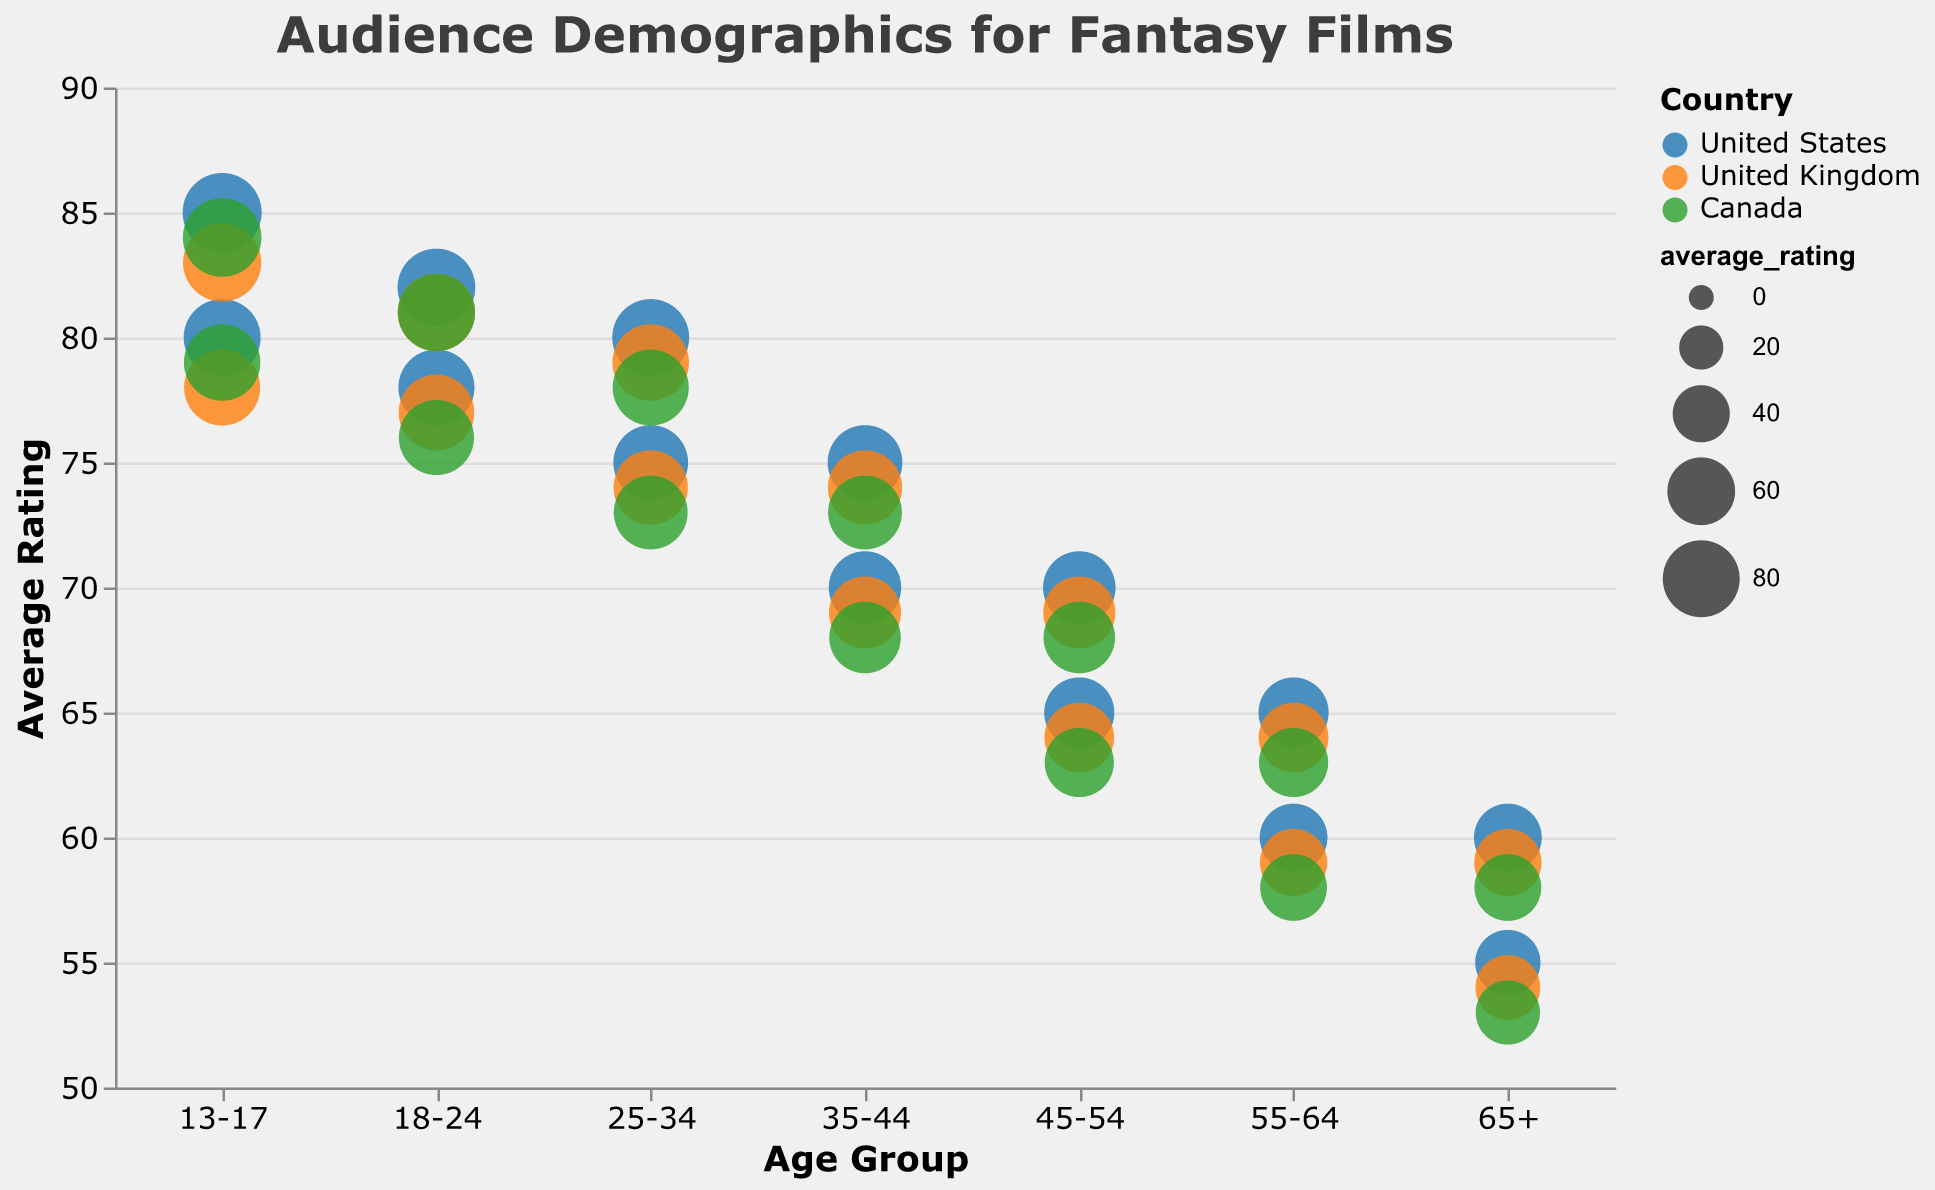What is the title of the chart? The title is displayed at the top of the chart and usually summarizes the content presented in the chart. Here, the title reads "Audience Demographics for Fantasy Films".
Answer: Audience Demographics for Fantasy Films How many age groups are represented in the chart? The age groups are represented on the x-axis and there are distinct labels for each group. By counting these labels, we can determine the number of age groups.
Answer: 7 Which gender has a higher average rating in the age group 13-17 in the United States? For the age group 13-17 in the United States, identify the shape type and look for the one with the higher y-axis value (average rating). Female (triangle) has an average rating of 85 while Male (circle) has an average rating of 80.
Answer: Female Among the three countries, which country's color represents Canada? Legend in the chart shows the correlation between the countries and their colors. According to the legend, Canada is represented by green.
Answer: Green What is the difference in average rating between the 13-17 age group and the 65+ age group for males in the United Kingdom? Locate the average ratings for males in the United Kingdom for the age groups 13-17 and 65+. For the 13-17 age group, the rating is 78. For the 65+ age group, it is 54. Subtract the latter from the former: 78 - 54 = 24.
Answer: 24 Which age group has the highest average rating overall? By examining the y-axis and identifying which bubble is at the highest point across all age groups, 13-17 females in the United States have the highest rating of 85. Verification with other data points confirms this.
Answer: 13-17 How do the average ratings of 18-24 males in the United States compare to 18-24 males in Canada? The average rating for 18-24 males in the United States is 78, whereas for 18-24 males in Canada, it is 76. Directly comparing these shows that the US has a higher rating.
Answer: US has higher rating Is there a significant gender disparity in ratings within the 45-54 age group in Canada? The 45-54 age group in Canada shows two ratings: males (63) and females (68). Calculating the difference shows a disparity of 5 points (68 - 63).
Answer: Yes Which country generally has the lowest average ratings across all age groups? By examining the placement of bubbles across all age groups for each country, it can be observed that the lowest general ratings tend to be associated with the Canada bubbles, specifically those for higher age groups.
Answer: Canada In the United Kingdom, which gender within the 35-44 age group has a higher average rating? Checking the age group 35-44 in the United Kingdom, the average rating for males is 69, and for females, it is 74. Females have a higher rating.
Answer: Female 